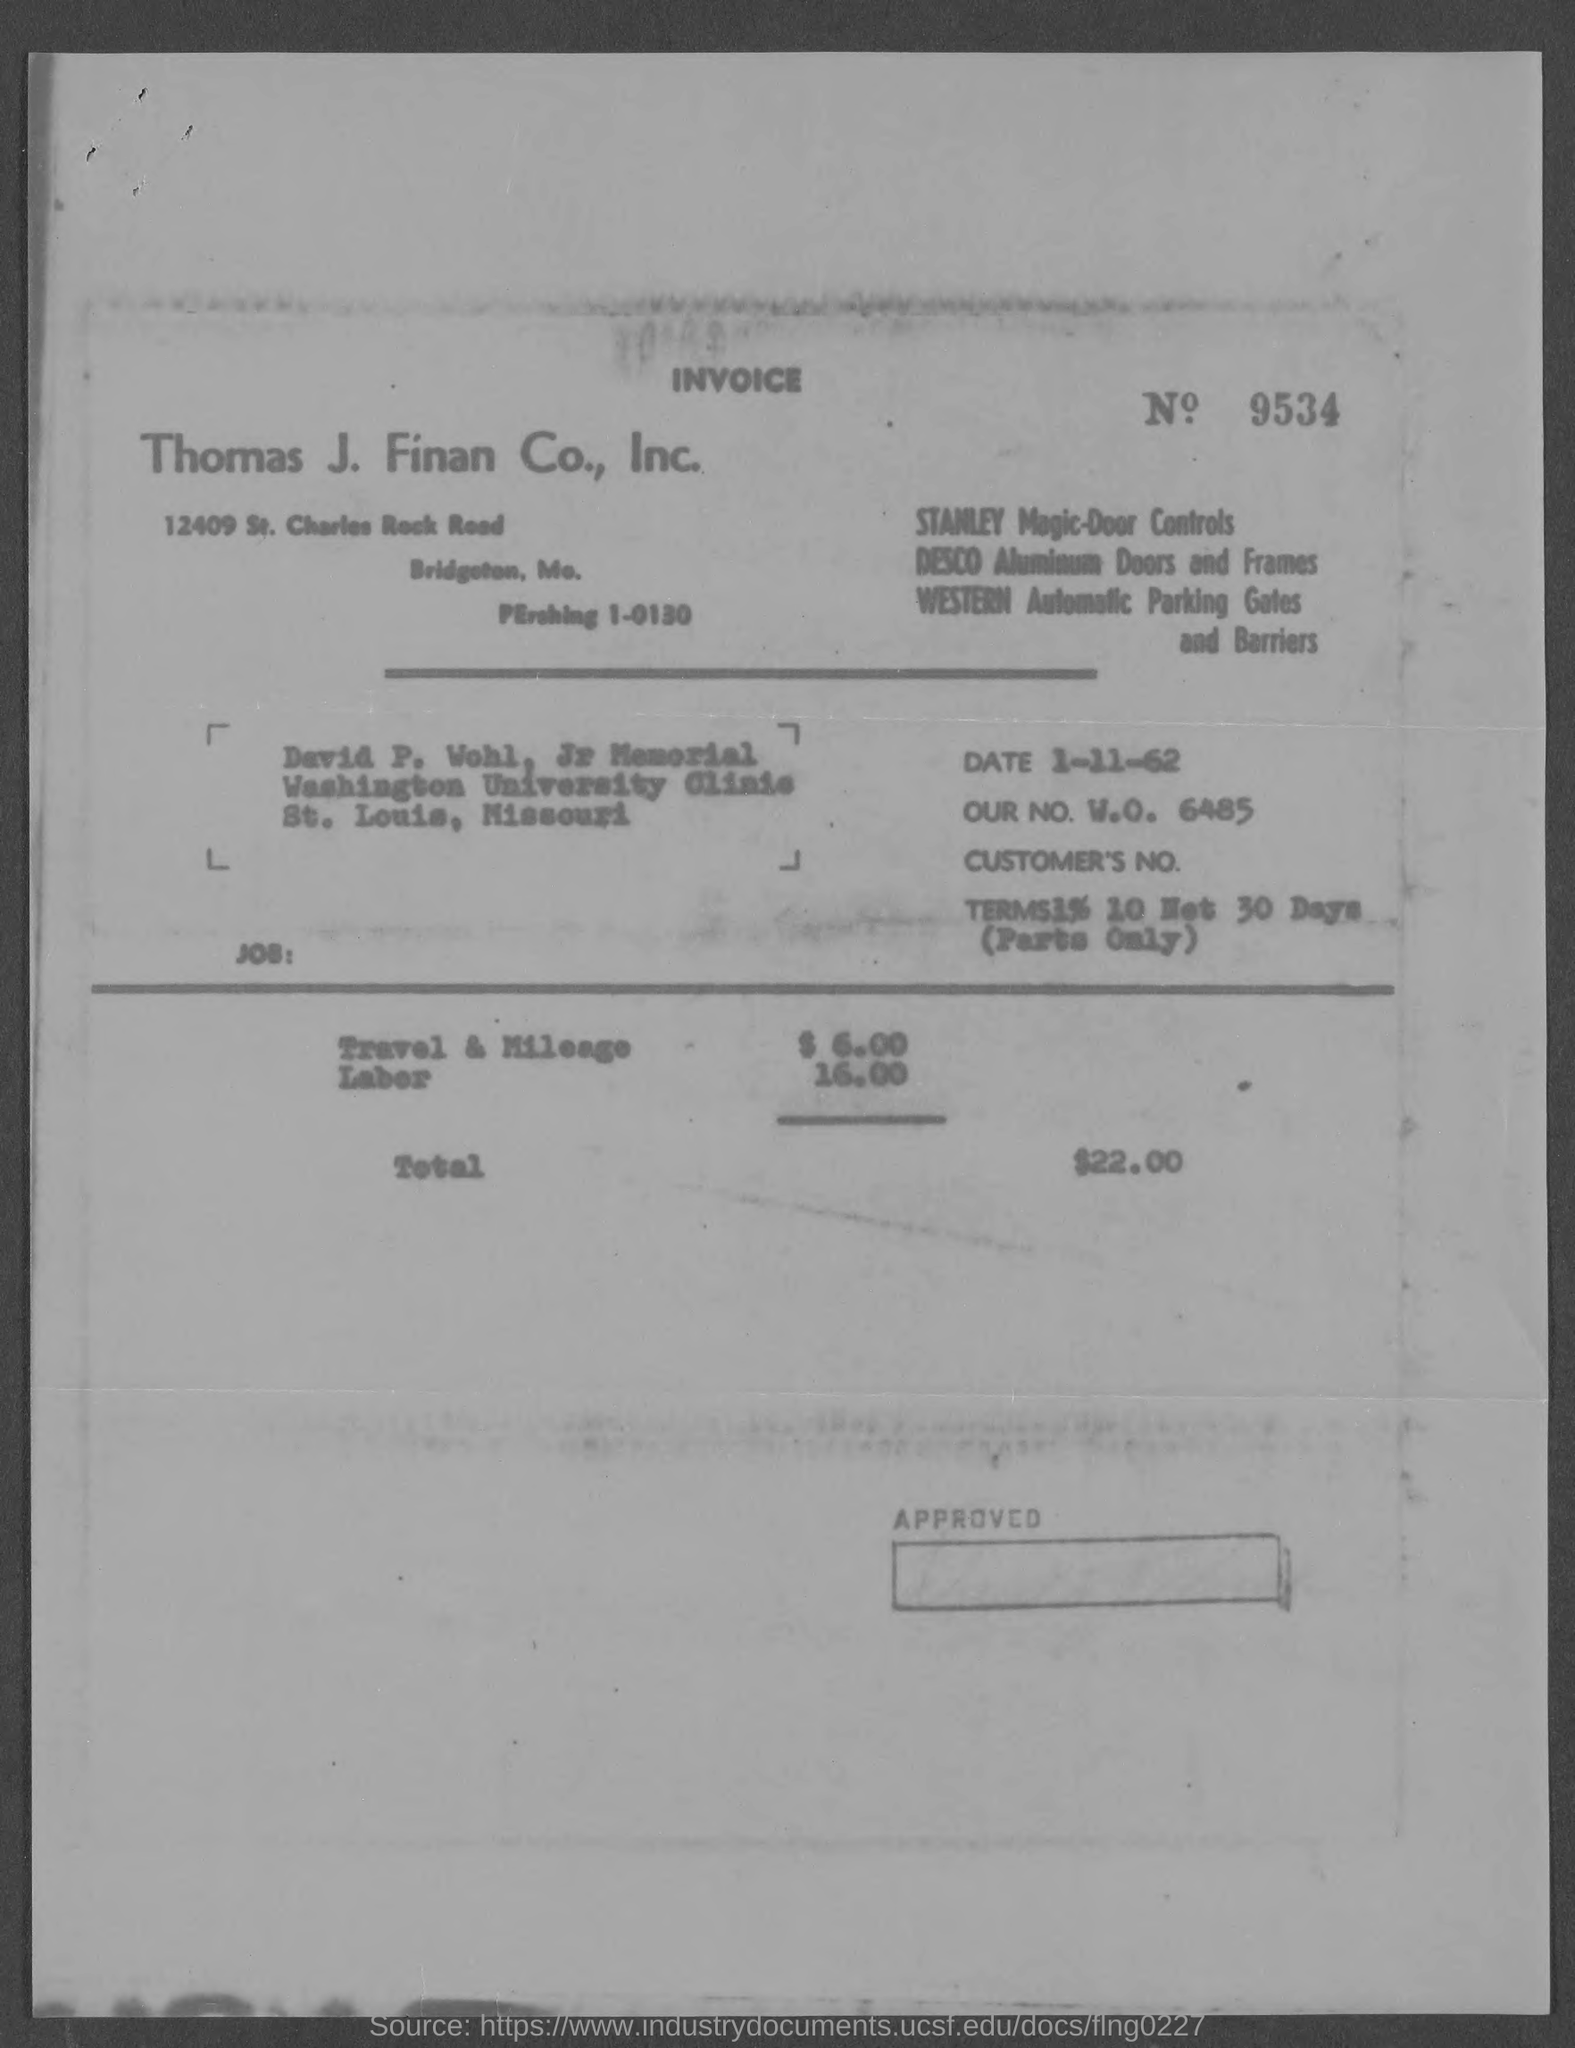Indicate a few pertinent items in this graphic. The invoice is being raised by Thomas J. Finan Co., Inc... The invoice number given in the document is 9534... The total amount of the invoice, as stated in the document, is 22.00... The invoice amount for travel and mileage is $6.00. The date mentioned in the invoice is November 1, 1962. 